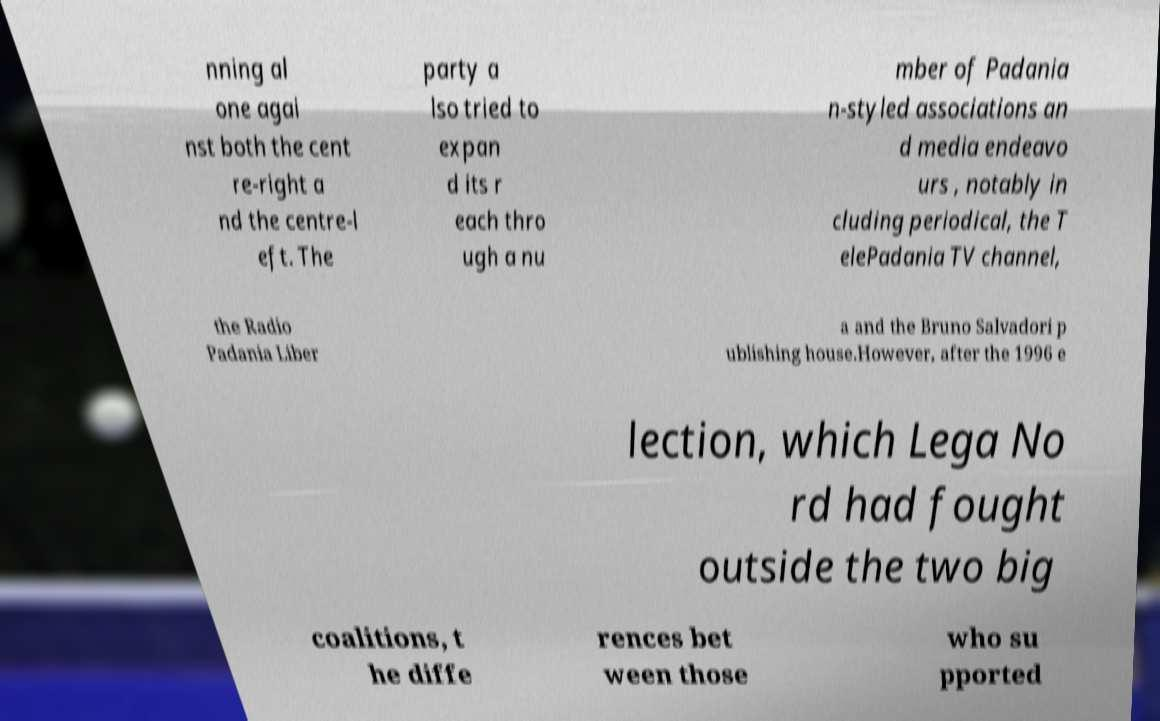There's text embedded in this image that I need extracted. Can you transcribe it verbatim? nning al one agai nst both the cent re-right a nd the centre-l eft. The party a lso tried to expan d its r each thro ugh a nu mber of Padania n-styled associations an d media endeavo urs , notably in cluding periodical, the T elePadania TV channel, the Radio Padania Liber a and the Bruno Salvadori p ublishing house.However, after the 1996 e lection, which Lega No rd had fought outside the two big coalitions, t he diffe rences bet ween those who su pported 